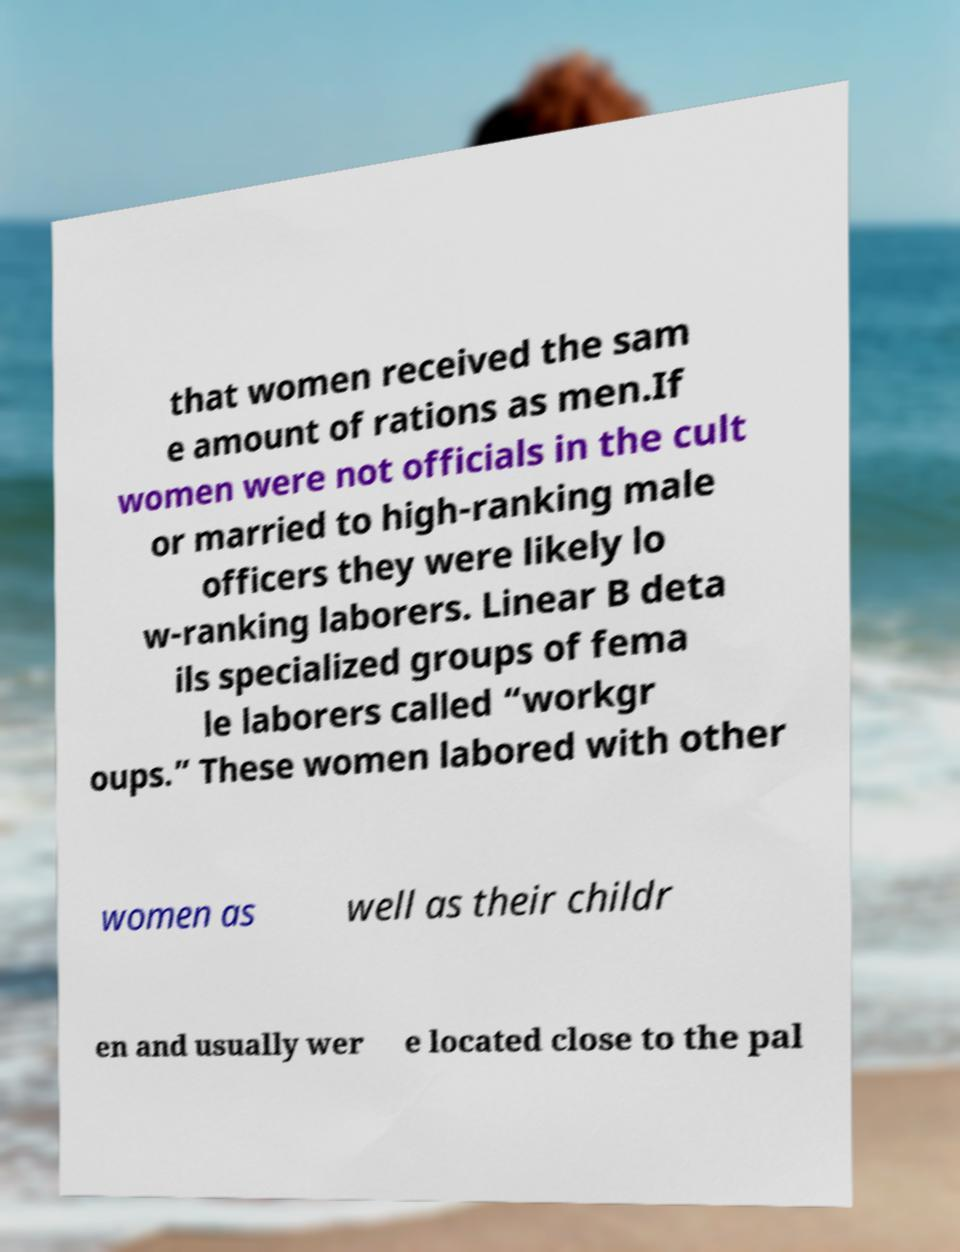Can you read and provide the text displayed in the image?This photo seems to have some interesting text. Can you extract and type it out for me? that women received the sam e amount of rations as men.If women were not officials in the cult or married to high-ranking male officers they were likely lo w-ranking laborers. Linear B deta ils specialized groups of fema le laborers called “workgr oups.” These women labored with other women as well as their childr en and usually wer e located close to the pal 